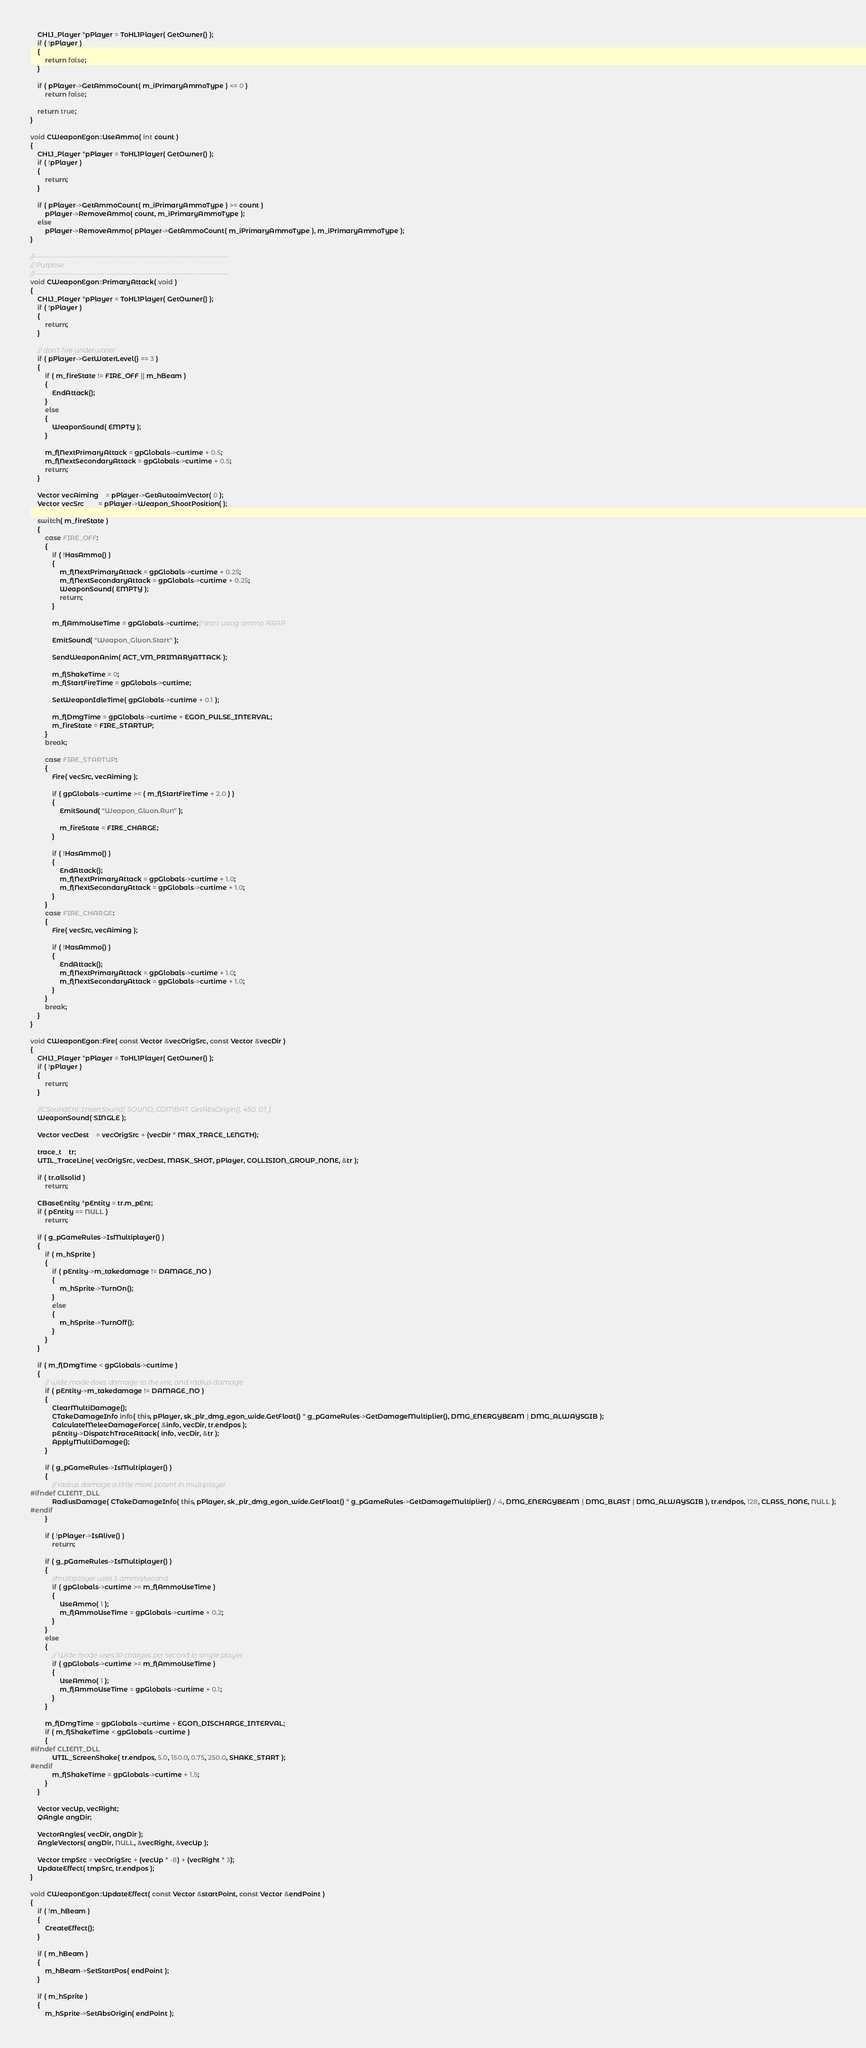Convert code to text. <code><loc_0><loc_0><loc_500><loc_500><_C++_>	CHL1_Player *pPlayer = ToHL1Player( GetOwner() );
	if ( !pPlayer )
	{
		return false;
	}

	if ( pPlayer->GetAmmoCount( m_iPrimaryAmmoType ) <= 0 )
		return false;

	return true;
}

void CWeaponEgon::UseAmmo( int count )
{
	CHL1_Player *pPlayer = ToHL1Player( GetOwner() );
	if ( !pPlayer )
	{
		return;
	}

	if ( pPlayer->GetAmmoCount( m_iPrimaryAmmoType ) >= count )
		pPlayer->RemoveAmmo( count, m_iPrimaryAmmoType );
	else
		pPlayer->RemoveAmmo( pPlayer->GetAmmoCount( m_iPrimaryAmmoType ), m_iPrimaryAmmoType );
}

//-----------------------------------------------------------------------------
// Purpose:
//-----------------------------------------------------------------------------
void CWeaponEgon::PrimaryAttack( void )
{
	CHL1_Player *pPlayer = ToHL1Player( GetOwner() );
	if ( !pPlayer )
	{
		return;
	}

	// don't fire underwater
	if ( pPlayer->GetWaterLevel() == 3 )
	{
		if ( m_fireState != FIRE_OFF || m_hBeam )
		{
			EndAttack();
		}
		else
		{
			WeaponSound( EMPTY );
		}

		m_flNextPrimaryAttack = gpGlobals->curtime + 0.5;
		m_flNextSecondaryAttack = gpGlobals->curtime + 0.5;
		return;
	}

	Vector vecAiming	= pPlayer->GetAutoaimVector( 0 );
	Vector vecSrc		= pPlayer->Weapon_ShootPosition( );

	switch( m_fireState )
	{
		case FIRE_OFF:
		{
			if ( !HasAmmo() )
			{
				m_flNextPrimaryAttack = gpGlobals->curtime + 0.25;
				m_flNextSecondaryAttack = gpGlobals->curtime + 0.25;
				WeaponSound( EMPTY );
				return;
			}

			m_flAmmoUseTime = gpGlobals->curtime;// start using ammo ASAP.

            EmitSound( "Weapon_Gluon.Start" );                

			SendWeaponAnim( ACT_VM_PRIMARYATTACK );
						
			m_flShakeTime = 0;
			m_flStartFireTime = gpGlobals->curtime;

			SetWeaponIdleTime( gpGlobals->curtime + 0.1 );

			m_flDmgTime = gpGlobals->curtime + EGON_PULSE_INTERVAL;
			m_fireState = FIRE_STARTUP;
		}
		break;

		case FIRE_STARTUP:
		{
			Fire( vecSrc, vecAiming );
		
			if ( gpGlobals->curtime >= ( m_flStartFireTime + 2.0 ) )
			{
                EmitSound( "Weapon_Gluon.Run" );

				m_fireState = FIRE_CHARGE;
			}

			if ( !HasAmmo() )
			{
				EndAttack();
				m_flNextPrimaryAttack = gpGlobals->curtime + 1.0;
				m_flNextSecondaryAttack = gpGlobals->curtime + 1.0;
			}
		}
		case FIRE_CHARGE:
		{
			Fire( vecSrc, vecAiming );
		
			if ( !HasAmmo() )
			{
				EndAttack();
				m_flNextPrimaryAttack = gpGlobals->curtime + 1.0;
				m_flNextSecondaryAttack = gpGlobals->curtime + 1.0;
			}
		}
		break;
	}
}

void CWeaponEgon::Fire( const Vector &vecOrigSrc, const Vector &vecDir )
{
	CHL1_Player *pPlayer = ToHL1Player( GetOwner() );
	if ( !pPlayer )
	{
		return;
	}

	//CSoundEnt::InsertSound( SOUND_COMBAT, GetAbsOrigin(), 450, 0.1 );
    WeaponSound( SINGLE );

	Vector vecDest	= vecOrigSrc + (vecDir * MAX_TRACE_LENGTH);

	trace_t	tr;
	UTIL_TraceLine( vecOrigSrc, vecDest, MASK_SHOT, pPlayer, COLLISION_GROUP_NONE, &tr );

	if ( tr.allsolid )
		return;

	CBaseEntity *pEntity = tr.m_pEnt;
	if ( pEntity == NULL )
		return;

	if ( g_pGameRules->IsMultiplayer() )
	{
		if ( m_hSprite )
		{
			if ( pEntity->m_takedamage != DAMAGE_NO )
			{
				m_hSprite->TurnOn();
			}
			else
			{
				m_hSprite->TurnOff();
			}
		}
	}

	if ( m_flDmgTime < gpGlobals->curtime )
	{
		// wide mode does damage to the ent, and radius damage
		if ( pEntity->m_takedamage != DAMAGE_NO )
		{
			ClearMultiDamage();
			CTakeDamageInfo info( this, pPlayer, sk_plr_dmg_egon_wide.GetFloat() * g_pGameRules->GetDamageMultiplier(), DMG_ENERGYBEAM | DMG_ALWAYSGIB );
			CalculateMeleeDamageForce( &info, vecDir, tr.endpos );
			pEntity->DispatchTraceAttack( info, vecDir, &tr );
			ApplyMultiDamage();
		}

		if ( g_pGameRules->IsMultiplayer() )
		{
			// radius damage a little more potent in multiplayer.
#ifndef CLIENT_DLL
			RadiusDamage( CTakeDamageInfo( this, pPlayer, sk_plr_dmg_egon_wide.GetFloat() * g_pGameRules->GetDamageMultiplier() / 4, DMG_ENERGYBEAM | DMG_BLAST | DMG_ALWAYSGIB ), tr.endpos, 128, CLASS_NONE, NULL );
#endif
		}

		if ( !pPlayer->IsAlive() )
			return;

		if ( g_pGameRules->IsMultiplayer() )
		{
			//multiplayer uses 5 ammo/second
			if ( gpGlobals->curtime >= m_flAmmoUseTime )
			{
				UseAmmo( 1 );
				m_flAmmoUseTime = gpGlobals->curtime + 0.2;
			}
		}
		else
		{
			// Wide mode uses 10 charges per second in single player
			if ( gpGlobals->curtime >= m_flAmmoUseTime )
			{
				UseAmmo( 1 );
				m_flAmmoUseTime = gpGlobals->curtime + 0.1;
			}
		}

		m_flDmgTime = gpGlobals->curtime + EGON_DISCHARGE_INTERVAL;
		if ( m_flShakeTime < gpGlobals->curtime )
		{
#ifndef CLIENT_DLL
			UTIL_ScreenShake( tr.endpos, 5.0, 150.0, 0.75, 250.0, SHAKE_START );
#endif
			m_flShakeTime = gpGlobals->curtime + 1.5;
		}
	}

	Vector vecUp, vecRight;
	QAngle angDir;

	VectorAngles( vecDir, angDir );
	AngleVectors( angDir, NULL, &vecRight, &vecUp );

	Vector tmpSrc = vecOrigSrc + (vecUp * -8) + (vecRight * 3);
	UpdateEffect( tmpSrc, tr.endpos );
}

void CWeaponEgon::UpdateEffect( const Vector &startPoint, const Vector &endPoint )
{
	if ( !m_hBeam )
	{
		CreateEffect();
	}

	if ( m_hBeam )
	{
		m_hBeam->SetStartPos( endPoint );
	}

	if ( m_hSprite )
	{
		m_hSprite->SetAbsOrigin( endPoint );
</code> 